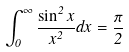Convert formula to latex. <formula><loc_0><loc_0><loc_500><loc_500>\int _ { 0 } ^ { \infty } \frac { \sin ^ { 2 } x } { x ^ { 2 } } d x = \frac { \pi } { 2 }</formula> 